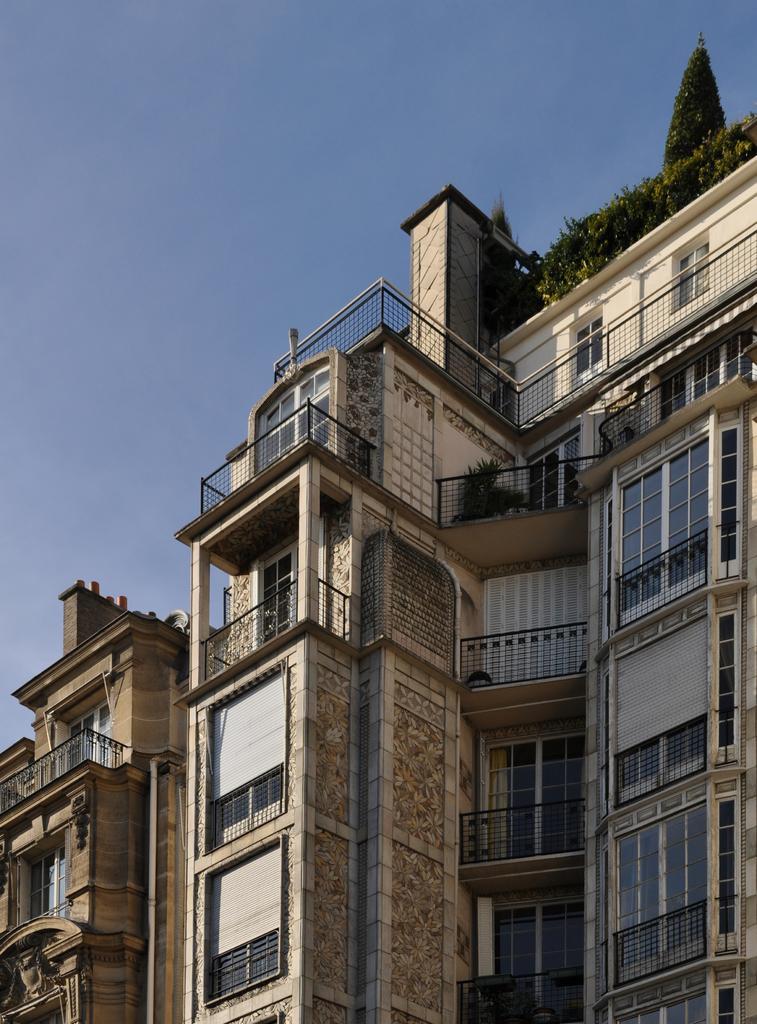Describe this image in one or two sentences. In this picture I can see buildings and few plants and I can see blue sky. 